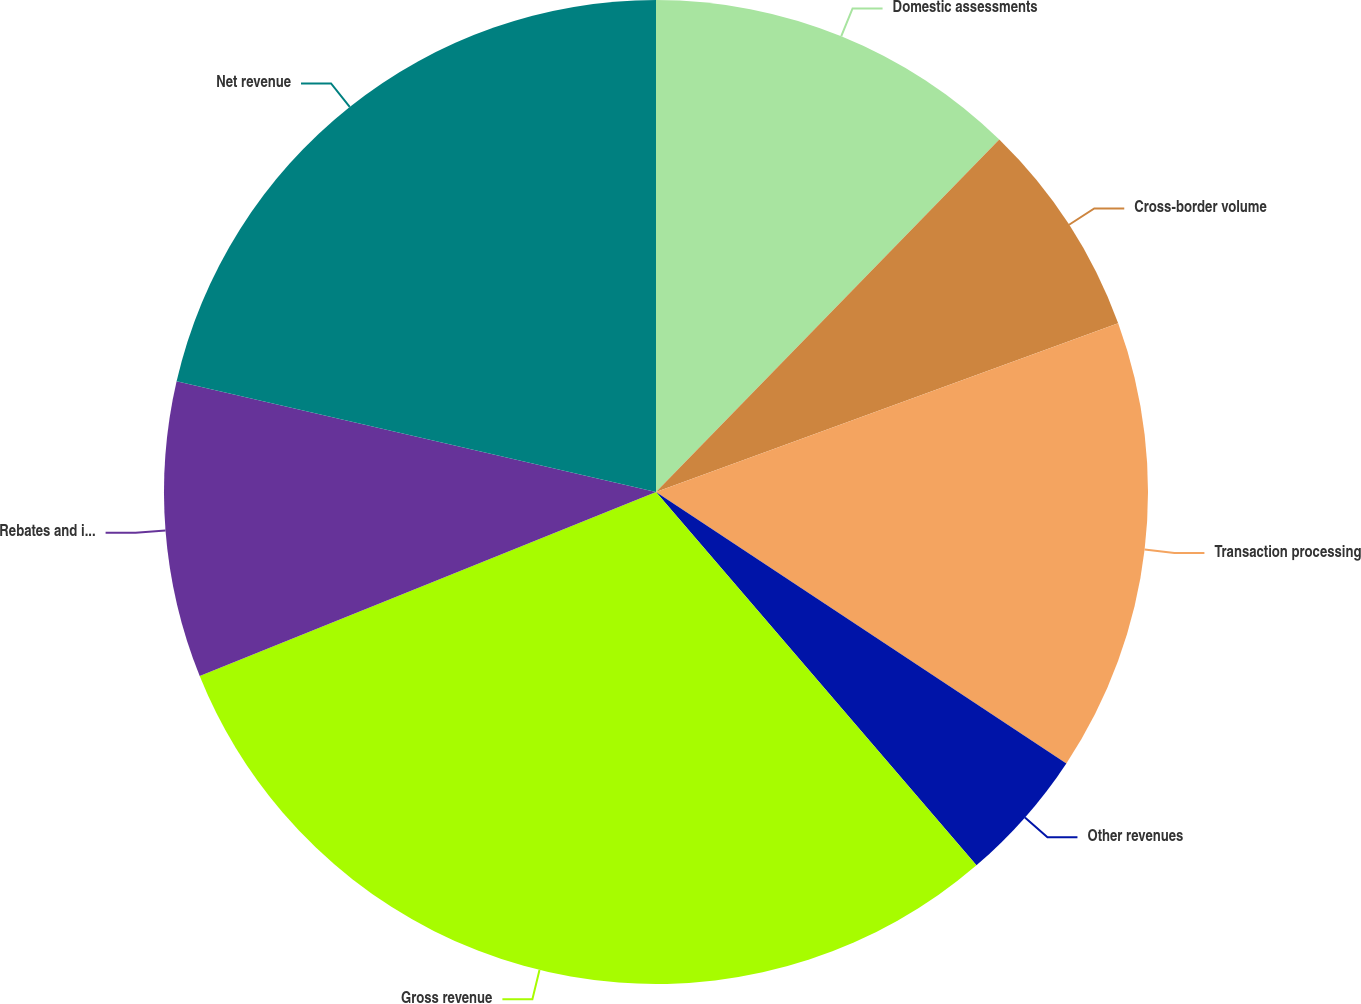Convert chart. <chart><loc_0><loc_0><loc_500><loc_500><pie_chart><fcel>Domestic assessments<fcel>Cross-border volume<fcel>Transaction processing<fcel>Other revenues<fcel>Gross revenue<fcel>Rebates and incentives<fcel>Net revenue<nl><fcel>12.29%<fcel>7.14%<fcel>14.87%<fcel>4.41%<fcel>30.19%<fcel>9.71%<fcel>21.39%<nl></chart> 